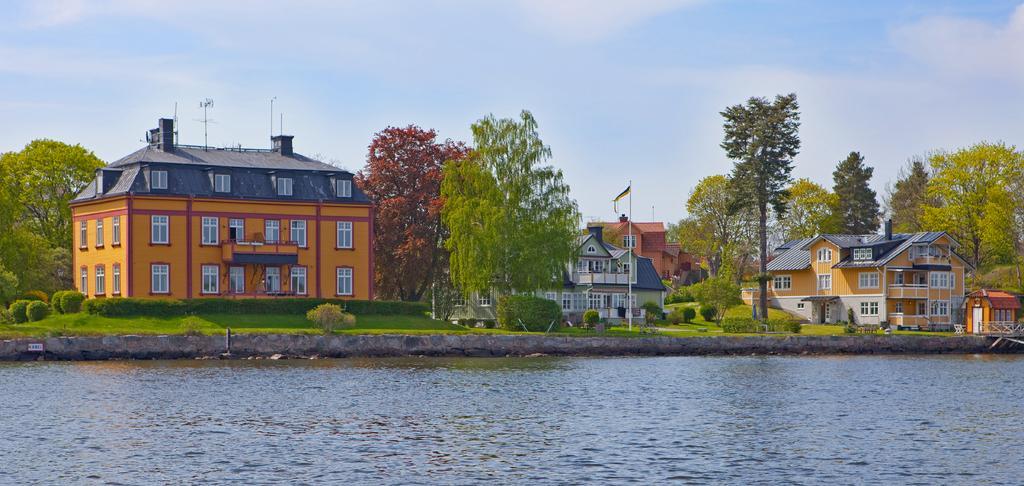Can you describe this image briefly? We can see water,grass and plants and we can see flag with pole. We can see buildings,trees and sky with clouds. 